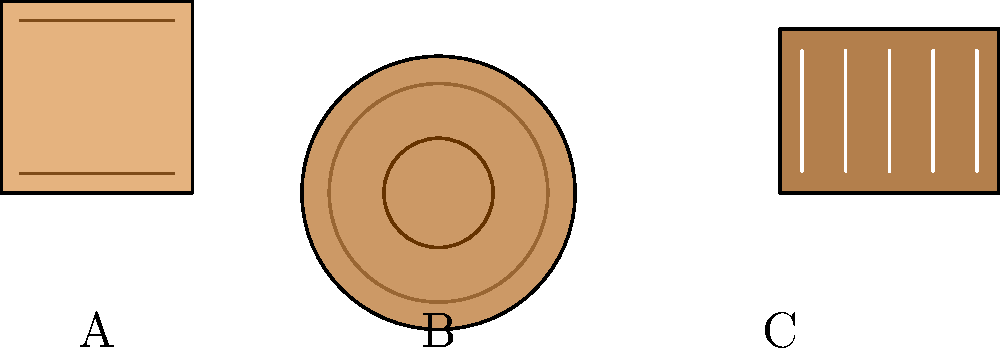Identify the Bollywood instrument represented by image B in the diagram above. To identify the Bollywood instrument represented by image B, let's analyze the characteristics of each image:

1. Image A shows a rectangular shape with strings, which is characteristic of a sitar.

2. Image B displays a circular shape with concentric circles. This is a top-down view of a drum-like instrument. In Bollywood music, the most common drum with this appearance is the tabla.

3. Image C presents a rectangular shape with white keys, resembling a keyboard instrument. This is likely a harmonium, a common instrument in Bollywood music.

Given these observations, we can conclude that image B represents a tabla, which is a pair of hand drums commonly used in Bollywood music to provide rhythmic accompaniment.

The tabla consists of two drums:
1. The daya (right drum): A smaller, wooden drum that produces higher-pitched sounds.
2. The baya (left drum): A larger, metal drum that produces lower-pitched sounds.

The image shows the top view of one of these drums, likely the daya, with its characteristic concentric circles representing the different tonal areas of the drumhead.
Answer: Tabla 